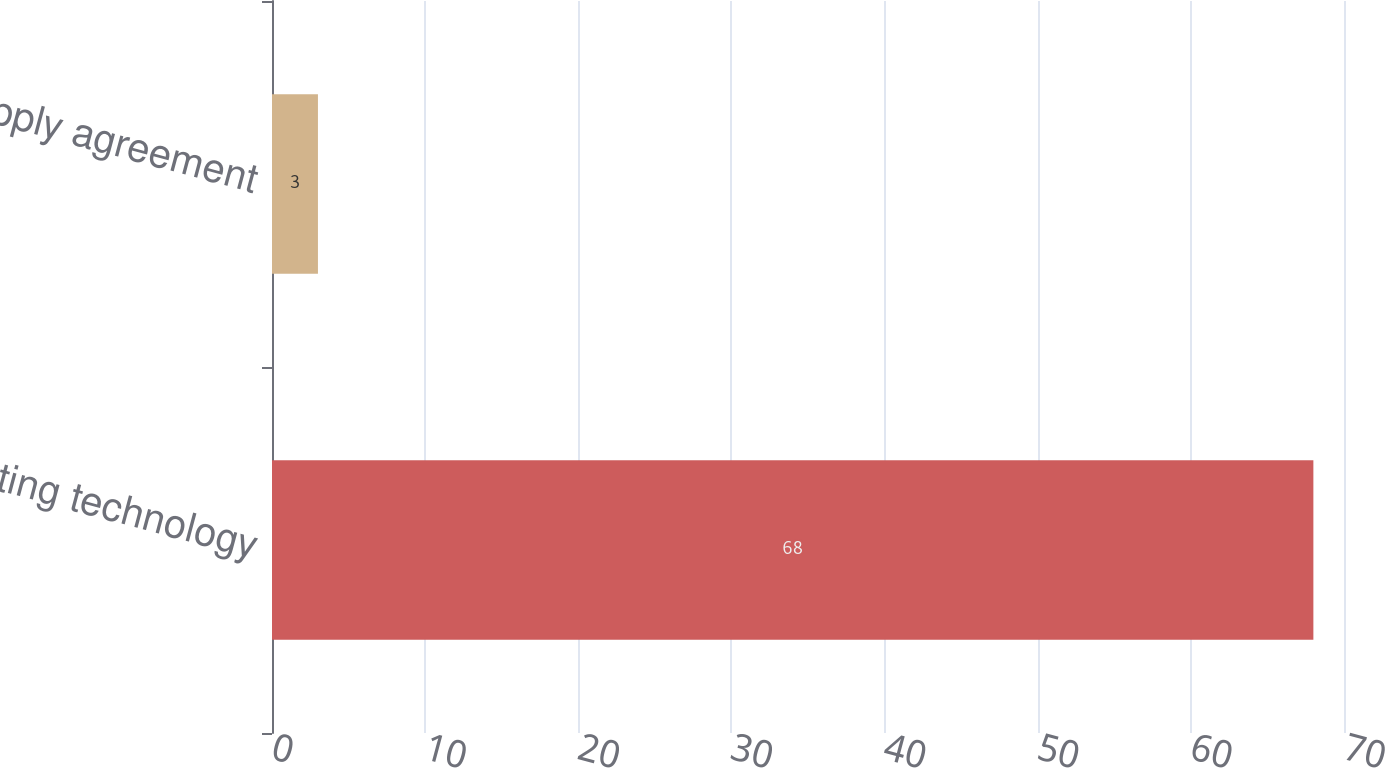Convert chart to OTSL. <chart><loc_0><loc_0><loc_500><loc_500><bar_chart><fcel>Existing technology<fcel>Supply agreement<nl><fcel>68<fcel>3<nl></chart> 